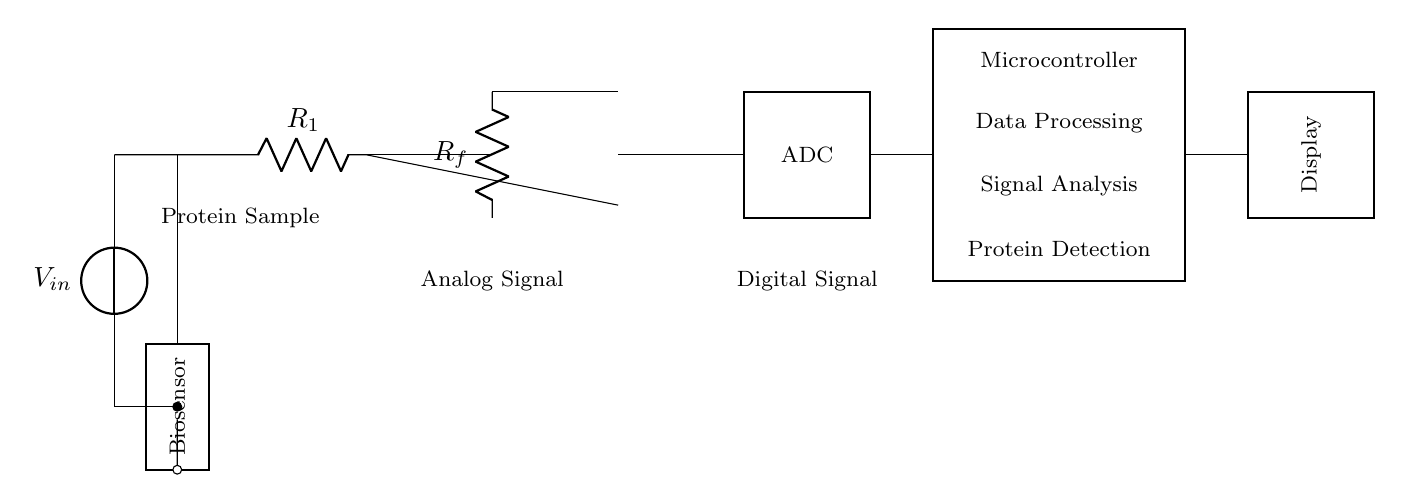What type of sensor is used in the circuit? The circuit diagram labels the component as a "Biosensor," indicating it is used for biological detection.
Answer: Biosensor What component converts the analog signal to a digital signal? The circuit shows an "ADC" (Analog to Digital Converter) which is responsible for this conversion.
Answer: ADC What is the purpose of the microcontroller in this circuit? The microcontroller is designated for data processing, signal analysis, and protein detection, as described in the labels.
Answer: Data processing How many resistors are present in the analog section? The diagram indicates that there are two resistors labeled as "R1" and "Rf" in the analog section of the circuit.
Answer: 2 What is the function of the operational amplifier? The operational amplifier is used to amplify the analog signal coming from the biosensor before it is sent to the ADC for digital conversion.
Answer: Amplification What type of signal is generated by the biosensor? The biosensor produces an "Analog Signal" which is then processed by the subsequent components of the circuit.
Answer: Analog Signal What is the output display labeled in the circuit? The output display is marked simply as "Display," which represents the final component that shows the detected protein data.
Answer: Display 